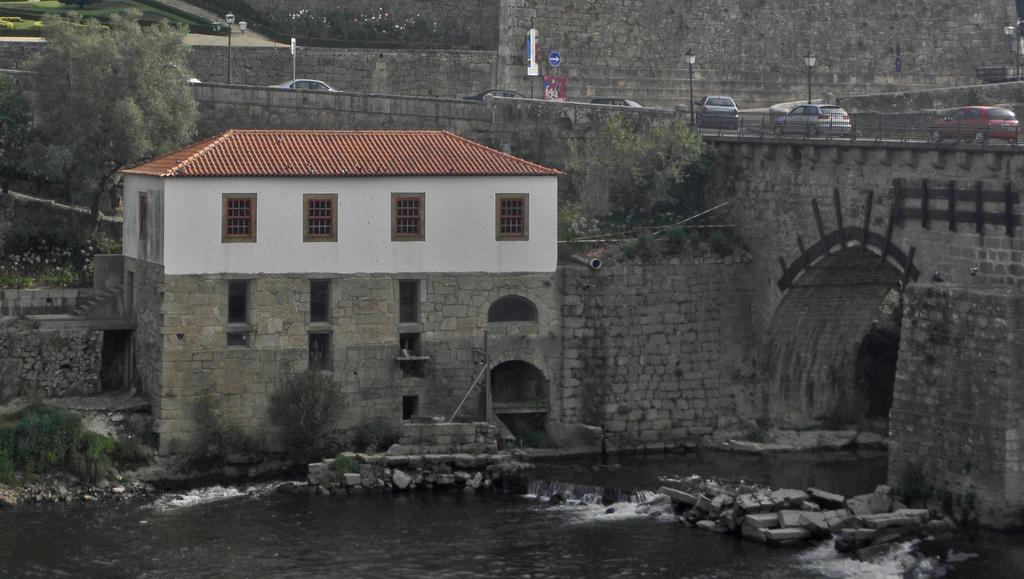In one or two sentences, can you explain what this image depicts? In the center of the image a house is there. On the right side of the image we can see a bridge, cars, electric light poles are there. At the top of the image grass, bushes are there. On the left side of the image trees are there. At the bottom of the image we can see water, rocks are there. In the background of the image wall is there. In the middle of the image sign boards are there. 